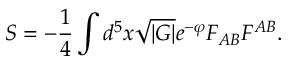Convert formula to latex. <formula><loc_0><loc_0><loc_500><loc_500>S = - \frac { 1 } { 4 } \int d ^ { 5 } x \sqrt { | G | } e ^ { - \varphi } F _ { A B } F ^ { A B } .</formula> 